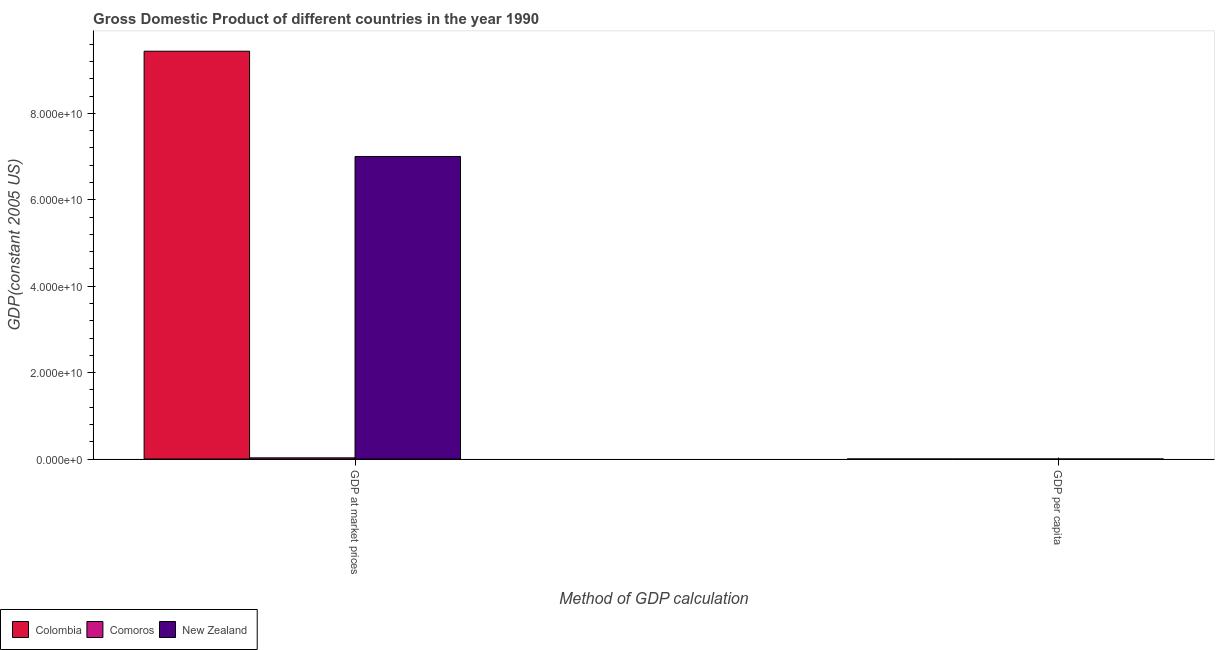How many groups of bars are there?
Offer a very short reply. 2. Are the number of bars per tick equal to the number of legend labels?
Make the answer very short. Yes. Are the number of bars on each tick of the X-axis equal?
Ensure brevity in your answer.  Yes. How many bars are there on the 2nd tick from the left?
Your answer should be compact. 3. How many bars are there on the 1st tick from the right?
Keep it short and to the point. 3. What is the label of the 2nd group of bars from the left?
Your response must be concise. GDP per capita. What is the gdp per capita in Colombia?
Make the answer very short. 2753.61. Across all countries, what is the maximum gdp per capita?
Your answer should be compact. 2.10e+04. Across all countries, what is the minimum gdp per capita?
Your response must be concise. 670.38. In which country was the gdp per capita maximum?
Ensure brevity in your answer.  New Zealand. In which country was the gdp at market prices minimum?
Ensure brevity in your answer.  Comoros. What is the total gdp per capita in the graph?
Your answer should be compact. 2.45e+04. What is the difference between the gdp at market prices in Colombia and that in New Zealand?
Offer a terse response. 2.44e+1. What is the difference between the gdp at market prices in New Zealand and the gdp per capita in Colombia?
Ensure brevity in your answer.  7.00e+1. What is the average gdp per capita per country?
Your response must be concise. 8150.17. What is the difference between the gdp at market prices and gdp per capita in New Zealand?
Offer a terse response. 7.00e+1. In how many countries, is the gdp per capita greater than 56000000000 US$?
Offer a very short reply. 0. What is the ratio of the gdp at market prices in Colombia to that in Comoros?
Keep it short and to the point. 339.09. What does the 2nd bar from the left in GDP per capita represents?
Ensure brevity in your answer.  Comoros. What does the 2nd bar from the right in GDP at market prices represents?
Offer a terse response. Comoros. How many countries are there in the graph?
Provide a succinct answer. 3. What is the difference between two consecutive major ticks on the Y-axis?
Offer a terse response. 2.00e+1. Does the graph contain any zero values?
Make the answer very short. No. Does the graph contain grids?
Make the answer very short. No. Where does the legend appear in the graph?
Offer a very short reply. Bottom left. How many legend labels are there?
Provide a short and direct response. 3. What is the title of the graph?
Keep it short and to the point. Gross Domestic Product of different countries in the year 1990. Does "Mali" appear as one of the legend labels in the graph?
Give a very brief answer. No. What is the label or title of the X-axis?
Ensure brevity in your answer.  Method of GDP calculation. What is the label or title of the Y-axis?
Provide a succinct answer. GDP(constant 2005 US). What is the GDP(constant 2005 US) of Colombia in GDP at market prices?
Your answer should be compact. 9.44e+1. What is the GDP(constant 2005 US) of Comoros in GDP at market prices?
Your answer should be very brief. 2.78e+08. What is the GDP(constant 2005 US) in New Zealand in GDP at market prices?
Provide a succinct answer. 7.00e+1. What is the GDP(constant 2005 US) in Colombia in GDP per capita?
Your answer should be very brief. 2753.61. What is the GDP(constant 2005 US) of Comoros in GDP per capita?
Offer a terse response. 670.38. What is the GDP(constant 2005 US) in New Zealand in GDP per capita?
Ensure brevity in your answer.  2.10e+04. Across all Method of GDP calculation, what is the maximum GDP(constant 2005 US) of Colombia?
Ensure brevity in your answer.  9.44e+1. Across all Method of GDP calculation, what is the maximum GDP(constant 2005 US) of Comoros?
Keep it short and to the point. 2.78e+08. Across all Method of GDP calculation, what is the maximum GDP(constant 2005 US) in New Zealand?
Your answer should be very brief. 7.00e+1. Across all Method of GDP calculation, what is the minimum GDP(constant 2005 US) of Colombia?
Your response must be concise. 2753.61. Across all Method of GDP calculation, what is the minimum GDP(constant 2005 US) in Comoros?
Make the answer very short. 670.38. Across all Method of GDP calculation, what is the minimum GDP(constant 2005 US) of New Zealand?
Make the answer very short. 2.10e+04. What is the total GDP(constant 2005 US) of Colombia in the graph?
Offer a very short reply. 9.44e+1. What is the total GDP(constant 2005 US) of Comoros in the graph?
Ensure brevity in your answer.  2.78e+08. What is the total GDP(constant 2005 US) of New Zealand in the graph?
Keep it short and to the point. 7.00e+1. What is the difference between the GDP(constant 2005 US) of Colombia in GDP at market prices and that in GDP per capita?
Offer a very short reply. 9.44e+1. What is the difference between the GDP(constant 2005 US) in Comoros in GDP at market prices and that in GDP per capita?
Give a very brief answer. 2.78e+08. What is the difference between the GDP(constant 2005 US) in New Zealand in GDP at market prices and that in GDP per capita?
Give a very brief answer. 7.00e+1. What is the difference between the GDP(constant 2005 US) of Colombia in GDP at market prices and the GDP(constant 2005 US) of Comoros in GDP per capita?
Offer a terse response. 9.44e+1. What is the difference between the GDP(constant 2005 US) in Colombia in GDP at market prices and the GDP(constant 2005 US) in New Zealand in GDP per capita?
Make the answer very short. 9.44e+1. What is the difference between the GDP(constant 2005 US) of Comoros in GDP at market prices and the GDP(constant 2005 US) of New Zealand in GDP per capita?
Ensure brevity in your answer.  2.78e+08. What is the average GDP(constant 2005 US) of Colombia per Method of GDP calculation?
Ensure brevity in your answer.  4.72e+1. What is the average GDP(constant 2005 US) of Comoros per Method of GDP calculation?
Ensure brevity in your answer.  1.39e+08. What is the average GDP(constant 2005 US) of New Zealand per Method of GDP calculation?
Provide a succinct answer. 3.50e+1. What is the difference between the GDP(constant 2005 US) in Colombia and GDP(constant 2005 US) in Comoros in GDP at market prices?
Make the answer very short. 9.41e+1. What is the difference between the GDP(constant 2005 US) of Colombia and GDP(constant 2005 US) of New Zealand in GDP at market prices?
Your answer should be very brief. 2.44e+1. What is the difference between the GDP(constant 2005 US) in Comoros and GDP(constant 2005 US) in New Zealand in GDP at market prices?
Your response must be concise. -6.97e+1. What is the difference between the GDP(constant 2005 US) in Colombia and GDP(constant 2005 US) in Comoros in GDP per capita?
Your response must be concise. 2083.23. What is the difference between the GDP(constant 2005 US) of Colombia and GDP(constant 2005 US) of New Zealand in GDP per capita?
Ensure brevity in your answer.  -1.83e+04. What is the difference between the GDP(constant 2005 US) of Comoros and GDP(constant 2005 US) of New Zealand in GDP per capita?
Offer a terse response. -2.04e+04. What is the ratio of the GDP(constant 2005 US) of Colombia in GDP at market prices to that in GDP per capita?
Ensure brevity in your answer.  3.43e+07. What is the ratio of the GDP(constant 2005 US) of Comoros in GDP at market prices to that in GDP per capita?
Make the answer very short. 4.15e+05. What is the ratio of the GDP(constant 2005 US) in New Zealand in GDP at market prices to that in GDP per capita?
Ensure brevity in your answer.  3.33e+06. What is the difference between the highest and the second highest GDP(constant 2005 US) of Colombia?
Keep it short and to the point. 9.44e+1. What is the difference between the highest and the second highest GDP(constant 2005 US) in Comoros?
Provide a short and direct response. 2.78e+08. What is the difference between the highest and the second highest GDP(constant 2005 US) of New Zealand?
Your response must be concise. 7.00e+1. What is the difference between the highest and the lowest GDP(constant 2005 US) of Colombia?
Keep it short and to the point. 9.44e+1. What is the difference between the highest and the lowest GDP(constant 2005 US) in Comoros?
Make the answer very short. 2.78e+08. What is the difference between the highest and the lowest GDP(constant 2005 US) of New Zealand?
Provide a short and direct response. 7.00e+1. 